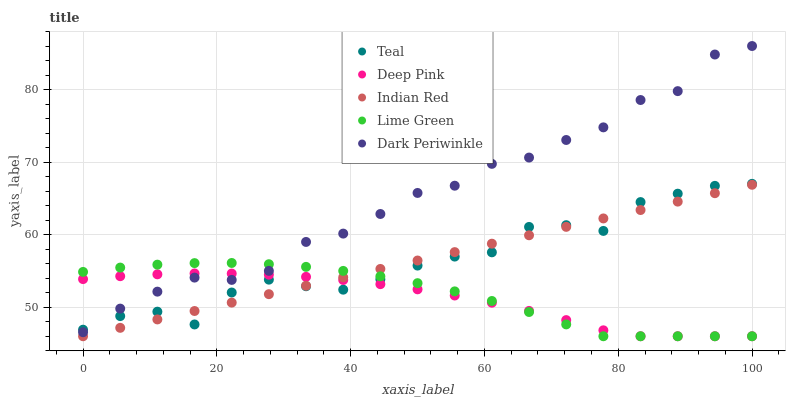Does Deep Pink have the minimum area under the curve?
Answer yes or no. Yes. Does Dark Periwinkle have the maximum area under the curve?
Answer yes or no. Yes. Does Lime Green have the minimum area under the curve?
Answer yes or no. No. Does Lime Green have the maximum area under the curve?
Answer yes or no. No. Is Indian Red the smoothest?
Answer yes or no. Yes. Is Teal the roughest?
Answer yes or no. Yes. Is Lime Green the smoothest?
Answer yes or no. No. Is Lime Green the roughest?
Answer yes or no. No. Does Deep Pink have the lowest value?
Answer yes or no. Yes. Does Teal have the lowest value?
Answer yes or no. No. Does Dark Periwinkle have the highest value?
Answer yes or no. Yes. Does Lime Green have the highest value?
Answer yes or no. No. Is Indian Red less than Dark Periwinkle?
Answer yes or no. Yes. Is Dark Periwinkle greater than Indian Red?
Answer yes or no. Yes. Does Deep Pink intersect Teal?
Answer yes or no. Yes. Is Deep Pink less than Teal?
Answer yes or no. No. Is Deep Pink greater than Teal?
Answer yes or no. No. Does Indian Red intersect Dark Periwinkle?
Answer yes or no. No. 